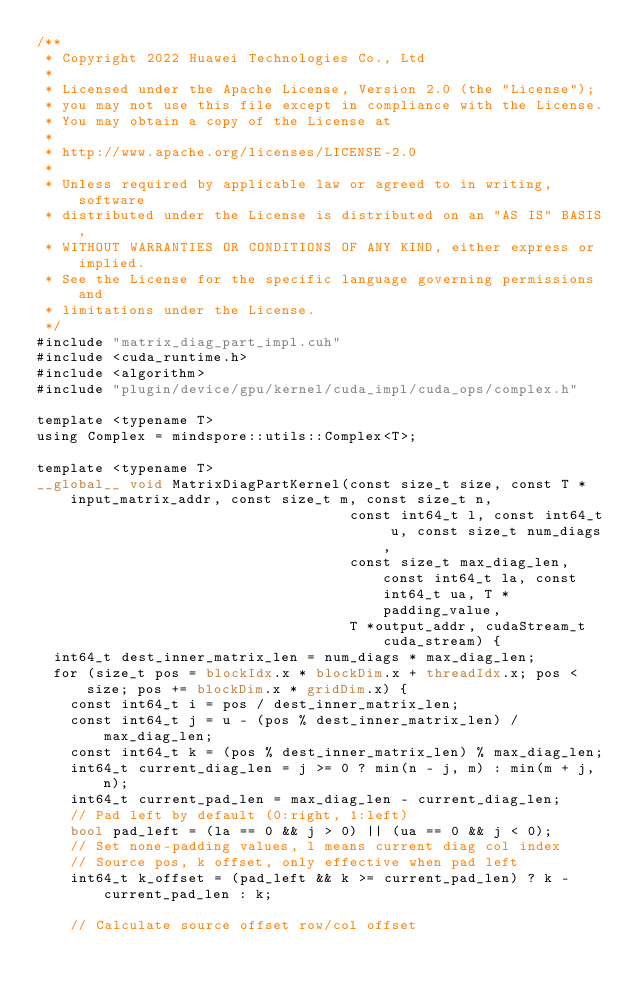<code> <loc_0><loc_0><loc_500><loc_500><_Cuda_>/**
 * Copyright 2022 Huawei Technologies Co., Ltd
 *
 * Licensed under the Apache License, Version 2.0 (the "License");
 * you may not use this file except in compliance with the License.
 * You may obtain a copy of the License at
 *
 * http://www.apache.org/licenses/LICENSE-2.0
 *
 * Unless required by applicable law or agreed to in writing, software
 * distributed under the License is distributed on an "AS IS" BASIS,
 * WITHOUT WARRANTIES OR CONDITIONS OF ANY KIND, either express or implied.
 * See the License for the specific language governing permissions and
 * limitations under the License.
 */
#include "matrix_diag_part_impl.cuh"
#include <cuda_runtime.h>
#include <algorithm>
#include "plugin/device/gpu/kernel/cuda_impl/cuda_ops/complex.h"

template <typename T>
using Complex = mindspore::utils::Complex<T>;

template <typename T>
__global__ void MatrixDiagPartKernel(const size_t size, const T *input_matrix_addr, const size_t m, const size_t n,
                                     const int64_t l, const int64_t u, const size_t num_diags,
                                     const size_t max_diag_len, const int64_t la, const int64_t ua, T *padding_value,
                                     T *output_addr, cudaStream_t cuda_stream) {
  int64_t dest_inner_matrix_len = num_diags * max_diag_len;
  for (size_t pos = blockIdx.x * blockDim.x + threadIdx.x; pos < size; pos += blockDim.x * gridDim.x) {
    const int64_t i = pos / dest_inner_matrix_len;
    const int64_t j = u - (pos % dest_inner_matrix_len) / max_diag_len;
    const int64_t k = (pos % dest_inner_matrix_len) % max_diag_len;
    int64_t current_diag_len = j >= 0 ? min(n - j, m) : min(m + j, n);
    int64_t current_pad_len = max_diag_len - current_diag_len;
    // Pad left by default (0:right, 1:left)
    bool pad_left = (la == 0 && j > 0) || (ua == 0 && j < 0);
    // Set none-padding values, l means current diag col index
    // Source pos, k offset, only effective when pad left
    int64_t k_offset = (pad_left && k >= current_pad_len) ? k - current_pad_len : k;

    // Calculate source offset row/col offset</code> 